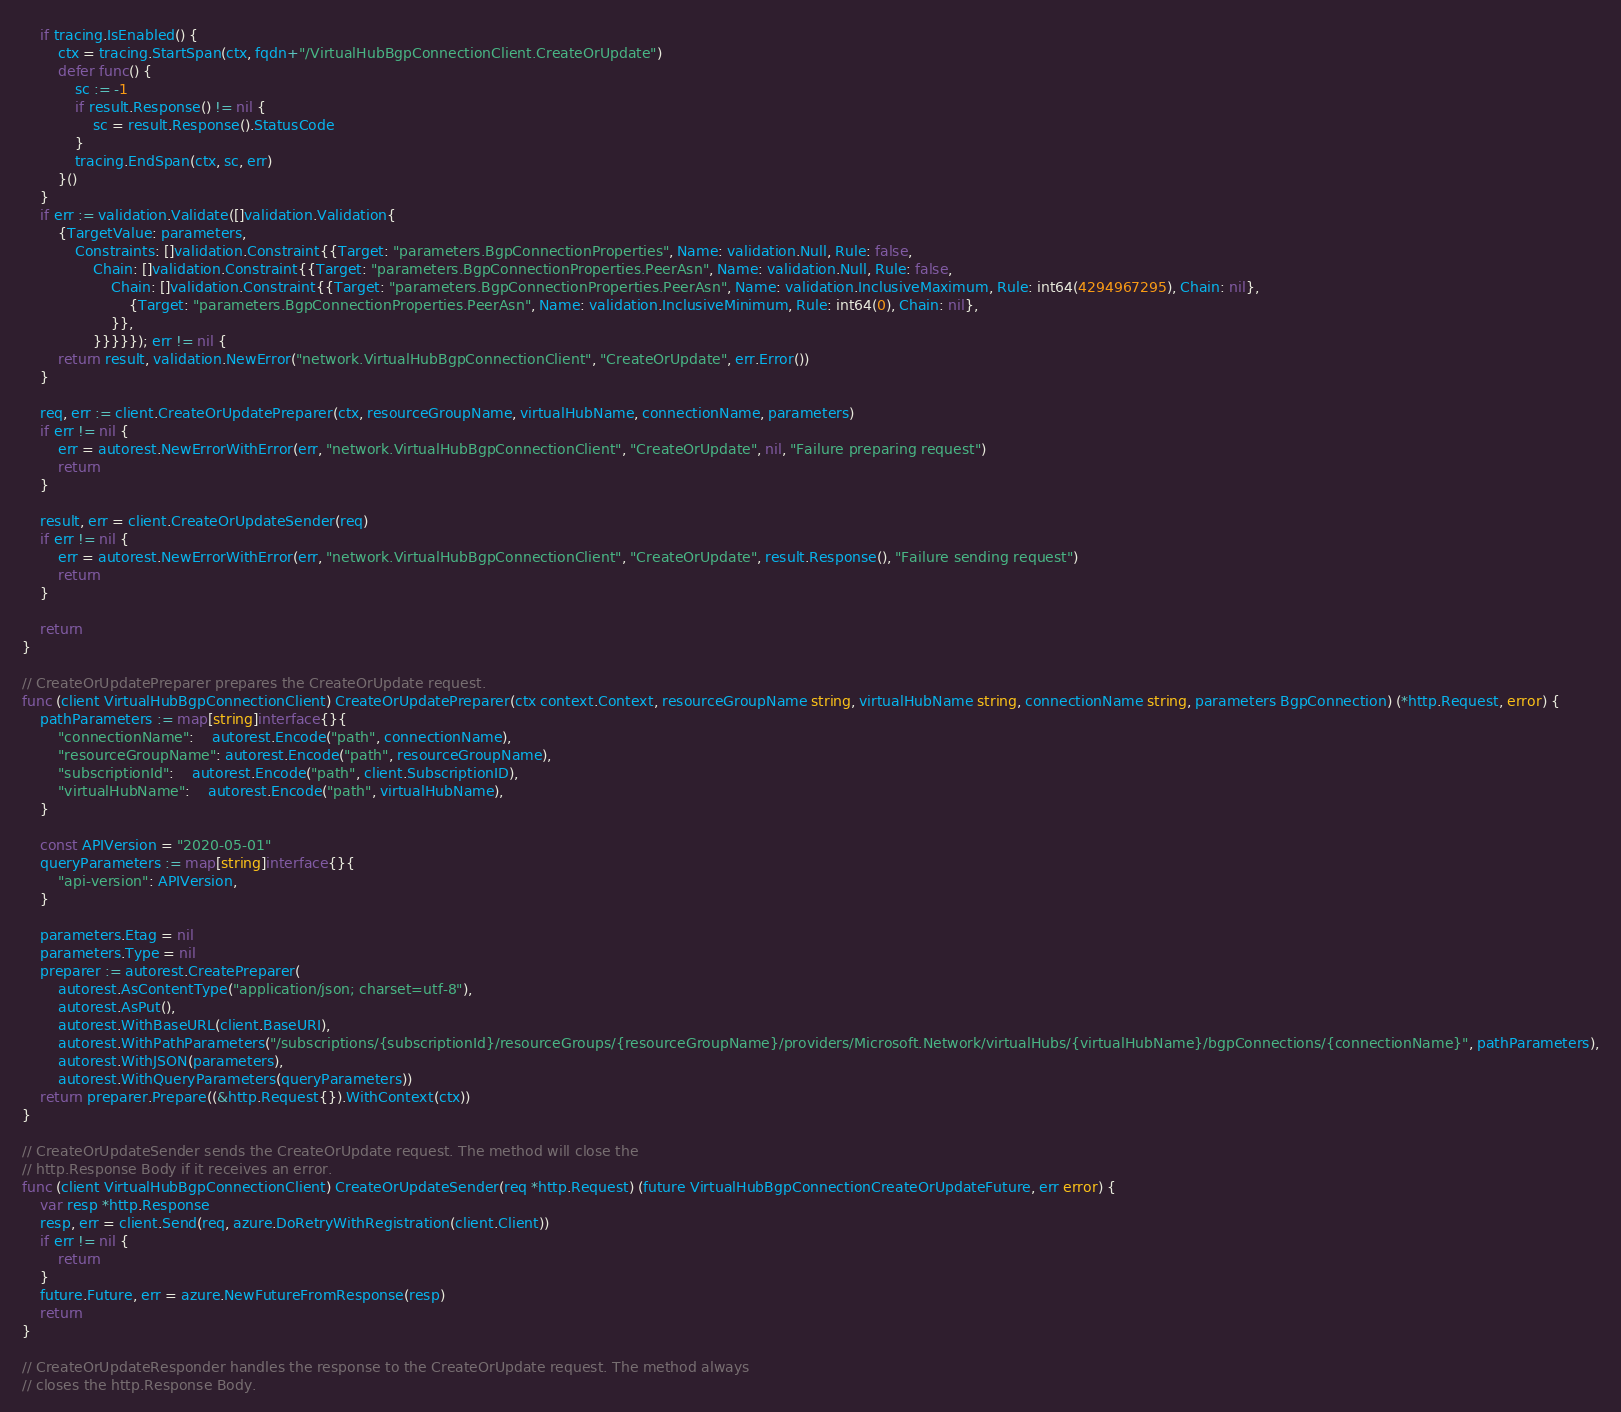Convert code to text. <code><loc_0><loc_0><loc_500><loc_500><_Go_>	if tracing.IsEnabled() {
		ctx = tracing.StartSpan(ctx, fqdn+"/VirtualHubBgpConnectionClient.CreateOrUpdate")
		defer func() {
			sc := -1
			if result.Response() != nil {
				sc = result.Response().StatusCode
			}
			tracing.EndSpan(ctx, sc, err)
		}()
	}
	if err := validation.Validate([]validation.Validation{
		{TargetValue: parameters,
			Constraints: []validation.Constraint{{Target: "parameters.BgpConnectionProperties", Name: validation.Null, Rule: false,
				Chain: []validation.Constraint{{Target: "parameters.BgpConnectionProperties.PeerAsn", Name: validation.Null, Rule: false,
					Chain: []validation.Constraint{{Target: "parameters.BgpConnectionProperties.PeerAsn", Name: validation.InclusiveMaximum, Rule: int64(4294967295), Chain: nil},
						{Target: "parameters.BgpConnectionProperties.PeerAsn", Name: validation.InclusiveMinimum, Rule: int64(0), Chain: nil},
					}},
				}}}}}); err != nil {
		return result, validation.NewError("network.VirtualHubBgpConnectionClient", "CreateOrUpdate", err.Error())
	}

	req, err := client.CreateOrUpdatePreparer(ctx, resourceGroupName, virtualHubName, connectionName, parameters)
	if err != nil {
		err = autorest.NewErrorWithError(err, "network.VirtualHubBgpConnectionClient", "CreateOrUpdate", nil, "Failure preparing request")
		return
	}

	result, err = client.CreateOrUpdateSender(req)
	if err != nil {
		err = autorest.NewErrorWithError(err, "network.VirtualHubBgpConnectionClient", "CreateOrUpdate", result.Response(), "Failure sending request")
		return
	}

	return
}

// CreateOrUpdatePreparer prepares the CreateOrUpdate request.
func (client VirtualHubBgpConnectionClient) CreateOrUpdatePreparer(ctx context.Context, resourceGroupName string, virtualHubName string, connectionName string, parameters BgpConnection) (*http.Request, error) {
	pathParameters := map[string]interface{}{
		"connectionName":    autorest.Encode("path", connectionName),
		"resourceGroupName": autorest.Encode("path", resourceGroupName),
		"subscriptionId":    autorest.Encode("path", client.SubscriptionID),
		"virtualHubName":    autorest.Encode("path", virtualHubName),
	}

	const APIVersion = "2020-05-01"
	queryParameters := map[string]interface{}{
		"api-version": APIVersion,
	}

	parameters.Etag = nil
	parameters.Type = nil
	preparer := autorest.CreatePreparer(
		autorest.AsContentType("application/json; charset=utf-8"),
		autorest.AsPut(),
		autorest.WithBaseURL(client.BaseURI),
		autorest.WithPathParameters("/subscriptions/{subscriptionId}/resourceGroups/{resourceGroupName}/providers/Microsoft.Network/virtualHubs/{virtualHubName}/bgpConnections/{connectionName}", pathParameters),
		autorest.WithJSON(parameters),
		autorest.WithQueryParameters(queryParameters))
	return preparer.Prepare((&http.Request{}).WithContext(ctx))
}

// CreateOrUpdateSender sends the CreateOrUpdate request. The method will close the
// http.Response Body if it receives an error.
func (client VirtualHubBgpConnectionClient) CreateOrUpdateSender(req *http.Request) (future VirtualHubBgpConnectionCreateOrUpdateFuture, err error) {
	var resp *http.Response
	resp, err = client.Send(req, azure.DoRetryWithRegistration(client.Client))
	if err != nil {
		return
	}
	future.Future, err = azure.NewFutureFromResponse(resp)
	return
}

// CreateOrUpdateResponder handles the response to the CreateOrUpdate request. The method always
// closes the http.Response Body.</code> 